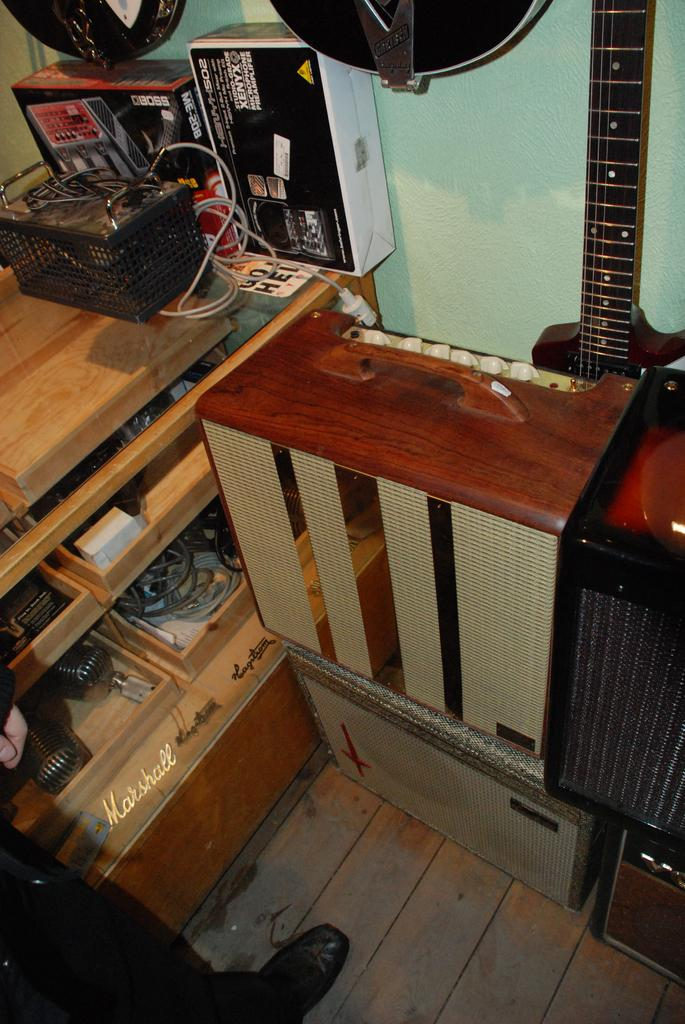What piece of furniture is present in the image? There is a table in the image. What object is hanging on the wall in the image? There is a guitar on the wall in the image. Can you describe the person visible in the image? Unfortunately, the provided facts do not give any information about the person's appearance or actions. How many crates are stacked on the table in the image? There is no crate present in the image. What type of beds can be seen in the image? There is no bed present in the image. 